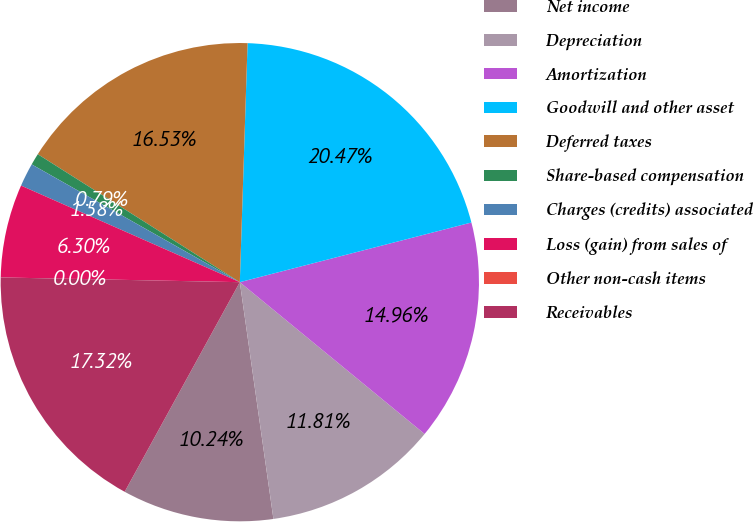<chart> <loc_0><loc_0><loc_500><loc_500><pie_chart><fcel>Net income<fcel>Depreciation<fcel>Amortization<fcel>Goodwill and other asset<fcel>Deferred taxes<fcel>Share-based compensation<fcel>Charges (credits) associated<fcel>Loss (gain) from sales of<fcel>Other non-cash items<fcel>Receivables<nl><fcel>10.24%<fcel>11.81%<fcel>14.96%<fcel>20.47%<fcel>16.53%<fcel>0.79%<fcel>1.58%<fcel>6.3%<fcel>0.0%<fcel>17.32%<nl></chart> 